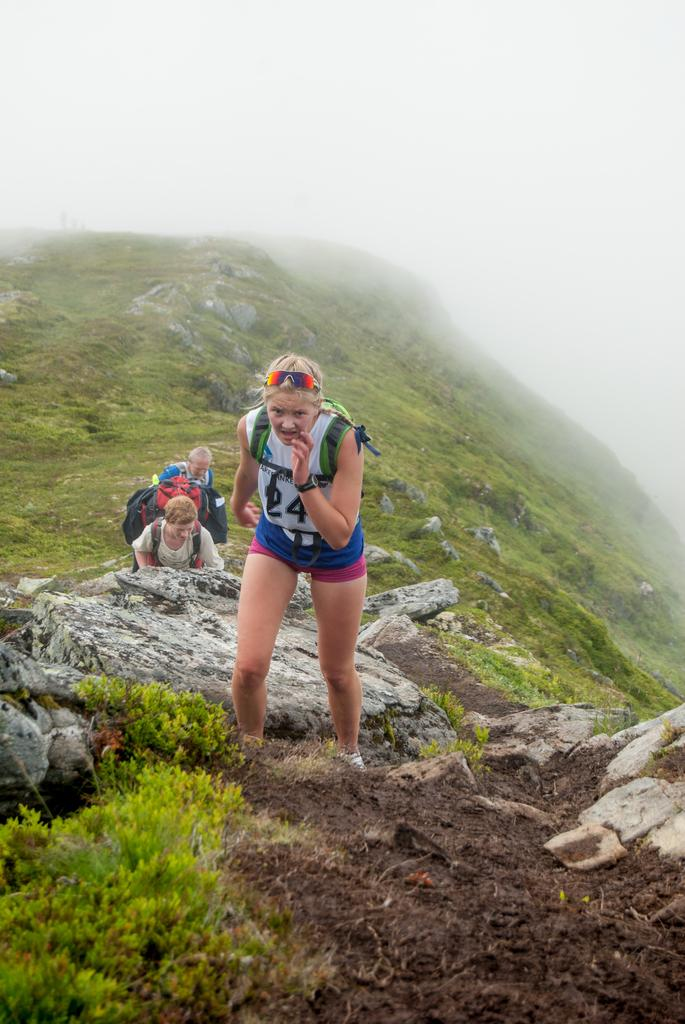What is happening on the hill in the image? There are persons on the hill in the image. What can be seen in the bottom left corner of the image? There are plants in the bottom left corner of the image. What is visible at the top of the image? There is a sky at the top of the image. Can you tell me how many creatures are swimming in the image? There are no creatures swimming in the image; it features persons on a hill and plants in the bottom left corner. What type of act is being performed by the persons in the image? The image does not depict any specific act being performed by the persons; they are simply standing or sitting on the hill. 